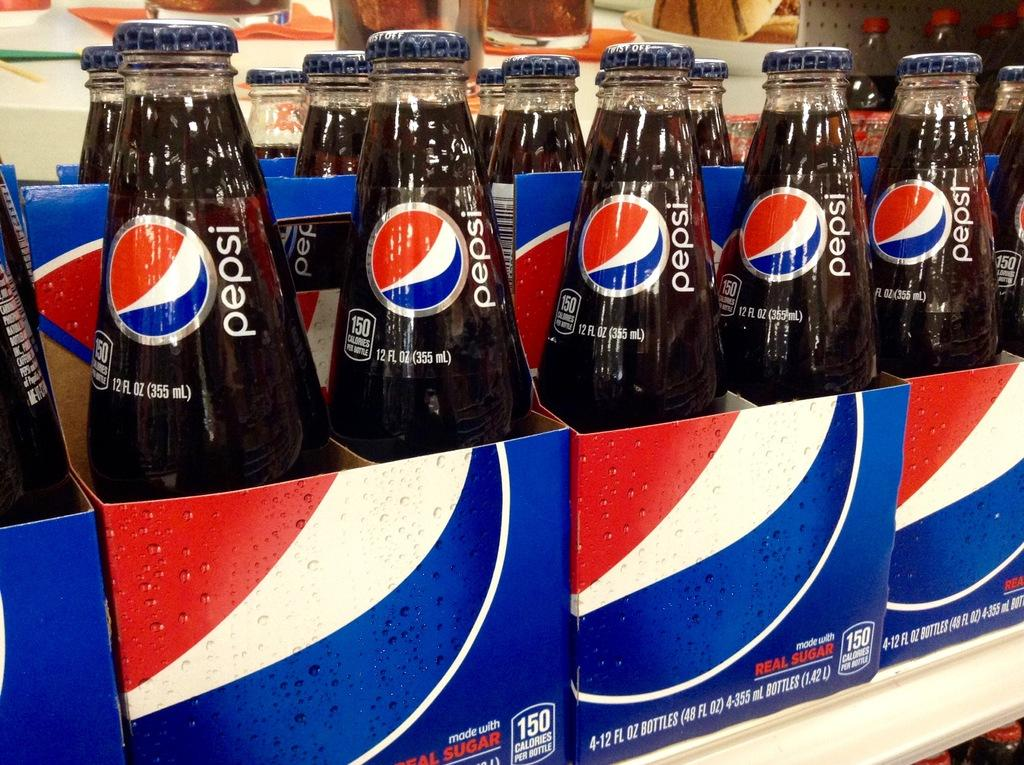<image>
Summarize the visual content of the image. colorful packs of Pepsi lining a grocery shelf 